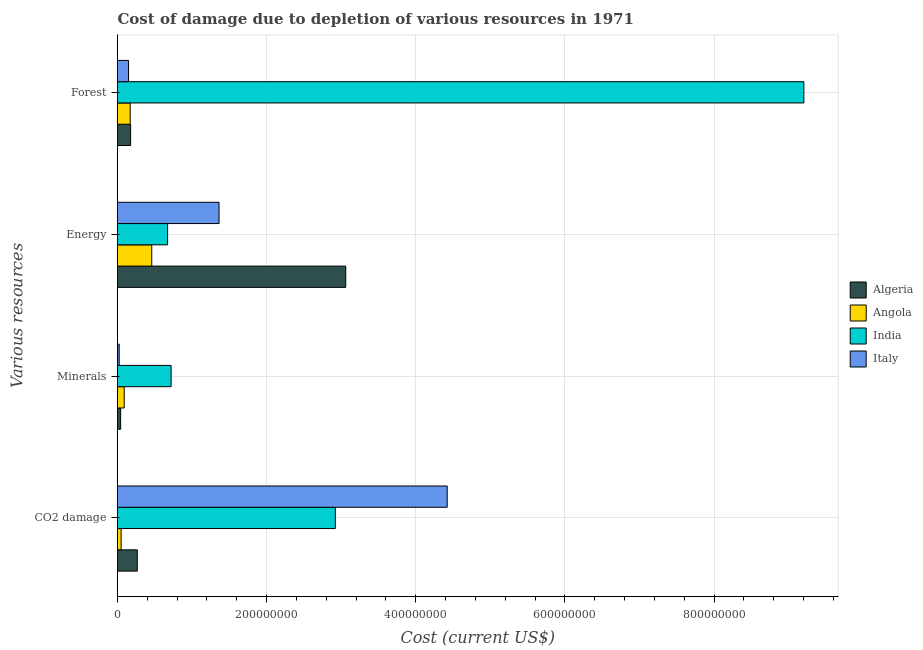How many different coloured bars are there?
Your answer should be very brief. 4. Are the number of bars per tick equal to the number of legend labels?
Offer a terse response. Yes. Are the number of bars on each tick of the Y-axis equal?
Provide a succinct answer. Yes. How many bars are there on the 2nd tick from the top?
Make the answer very short. 4. What is the label of the 1st group of bars from the top?
Ensure brevity in your answer.  Forest. What is the cost of damage due to depletion of minerals in Algeria?
Your answer should be compact. 4.19e+06. Across all countries, what is the maximum cost of damage due to depletion of minerals?
Offer a very short reply. 7.19e+07. Across all countries, what is the minimum cost of damage due to depletion of coal?
Make the answer very short. 4.84e+06. In which country was the cost of damage due to depletion of energy maximum?
Your response must be concise. Algeria. In which country was the cost of damage due to depletion of minerals minimum?
Give a very brief answer. Italy. What is the total cost of damage due to depletion of coal in the graph?
Your response must be concise. 7.66e+08. What is the difference between the cost of damage due to depletion of energy in Angola and that in Algeria?
Offer a terse response. -2.60e+08. What is the difference between the cost of damage due to depletion of forests in Algeria and the cost of damage due to depletion of minerals in India?
Ensure brevity in your answer.  -5.43e+07. What is the average cost of damage due to depletion of minerals per country?
Keep it short and to the point. 2.18e+07. What is the difference between the cost of damage due to depletion of energy and cost of damage due to depletion of coal in Italy?
Keep it short and to the point. -3.06e+08. In how many countries, is the cost of damage due to depletion of forests greater than 480000000 US$?
Provide a succinct answer. 1. What is the ratio of the cost of damage due to depletion of coal in Angola to that in Italy?
Keep it short and to the point. 0.01. Is the difference between the cost of damage due to depletion of energy in Algeria and Angola greater than the difference between the cost of damage due to depletion of coal in Algeria and Angola?
Provide a succinct answer. Yes. What is the difference between the highest and the second highest cost of damage due to depletion of minerals?
Offer a terse response. 6.29e+07. What is the difference between the highest and the lowest cost of damage due to depletion of forests?
Keep it short and to the point. 9.06e+08. In how many countries, is the cost of damage due to depletion of energy greater than the average cost of damage due to depletion of energy taken over all countries?
Keep it short and to the point. 1. Is the sum of the cost of damage due to depletion of energy in India and Algeria greater than the maximum cost of damage due to depletion of minerals across all countries?
Your answer should be very brief. Yes. What does the 1st bar from the top in Minerals represents?
Provide a short and direct response. Italy. Is it the case that in every country, the sum of the cost of damage due to depletion of coal and cost of damage due to depletion of minerals is greater than the cost of damage due to depletion of energy?
Your response must be concise. No. How many bars are there?
Your answer should be compact. 16. How many countries are there in the graph?
Give a very brief answer. 4. Are the values on the major ticks of X-axis written in scientific E-notation?
Keep it short and to the point. No. Does the graph contain grids?
Provide a short and direct response. Yes. How are the legend labels stacked?
Make the answer very short. Vertical. What is the title of the graph?
Your answer should be very brief. Cost of damage due to depletion of various resources in 1971 . Does "United States" appear as one of the legend labels in the graph?
Your response must be concise. No. What is the label or title of the X-axis?
Offer a terse response. Cost (current US$). What is the label or title of the Y-axis?
Your answer should be compact. Various resources. What is the Cost (current US$) of Algeria in CO2 damage?
Make the answer very short. 2.65e+07. What is the Cost (current US$) of Angola in CO2 damage?
Make the answer very short. 4.84e+06. What is the Cost (current US$) in India in CO2 damage?
Offer a very short reply. 2.92e+08. What is the Cost (current US$) of Italy in CO2 damage?
Your answer should be very brief. 4.42e+08. What is the Cost (current US$) of Algeria in Minerals?
Your answer should be very brief. 4.19e+06. What is the Cost (current US$) in Angola in Minerals?
Give a very brief answer. 8.98e+06. What is the Cost (current US$) in India in Minerals?
Provide a short and direct response. 7.19e+07. What is the Cost (current US$) in Italy in Minerals?
Your answer should be very brief. 2.28e+06. What is the Cost (current US$) of Algeria in Energy?
Your answer should be very brief. 3.06e+08. What is the Cost (current US$) in Angola in Energy?
Provide a succinct answer. 4.59e+07. What is the Cost (current US$) in India in Energy?
Provide a short and direct response. 6.72e+07. What is the Cost (current US$) in Italy in Energy?
Offer a very short reply. 1.36e+08. What is the Cost (current US$) in Algeria in Forest?
Provide a succinct answer. 1.76e+07. What is the Cost (current US$) of Angola in Forest?
Ensure brevity in your answer.  1.70e+07. What is the Cost (current US$) of India in Forest?
Your answer should be compact. 9.20e+08. What is the Cost (current US$) in Italy in Forest?
Your answer should be compact. 1.48e+07. Across all Various resources, what is the maximum Cost (current US$) in Algeria?
Give a very brief answer. 3.06e+08. Across all Various resources, what is the maximum Cost (current US$) of Angola?
Offer a very short reply. 4.59e+07. Across all Various resources, what is the maximum Cost (current US$) in India?
Keep it short and to the point. 9.20e+08. Across all Various resources, what is the maximum Cost (current US$) of Italy?
Give a very brief answer. 4.42e+08. Across all Various resources, what is the minimum Cost (current US$) in Algeria?
Provide a short and direct response. 4.19e+06. Across all Various resources, what is the minimum Cost (current US$) of Angola?
Give a very brief answer. 4.84e+06. Across all Various resources, what is the minimum Cost (current US$) of India?
Your response must be concise. 6.72e+07. Across all Various resources, what is the minimum Cost (current US$) of Italy?
Your answer should be compact. 2.28e+06. What is the total Cost (current US$) in Algeria in the graph?
Your answer should be compact. 3.54e+08. What is the total Cost (current US$) in Angola in the graph?
Make the answer very short. 7.68e+07. What is the total Cost (current US$) of India in the graph?
Your response must be concise. 1.35e+09. What is the total Cost (current US$) of Italy in the graph?
Offer a terse response. 5.95e+08. What is the difference between the Cost (current US$) in Algeria in CO2 damage and that in Minerals?
Your answer should be compact. 2.23e+07. What is the difference between the Cost (current US$) of Angola in CO2 damage and that in Minerals?
Your answer should be compact. -4.14e+06. What is the difference between the Cost (current US$) in India in CO2 damage and that in Minerals?
Provide a succinct answer. 2.20e+08. What is the difference between the Cost (current US$) in Italy in CO2 damage and that in Minerals?
Make the answer very short. 4.40e+08. What is the difference between the Cost (current US$) of Algeria in CO2 damage and that in Energy?
Your answer should be very brief. -2.80e+08. What is the difference between the Cost (current US$) in Angola in CO2 damage and that in Energy?
Your answer should be very brief. -4.11e+07. What is the difference between the Cost (current US$) of India in CO2 damage and that in Energy?
Ensure brevity in your answer.  2.25e+08. What is the difference between the Cost (current US$) in Italy in CO2 damage and that in Energy?
Offer a terse response. 3.06e+08. What is the difference between the Cost (current US$) in Algeria in CO2 damage and that in Forest?
Your answer should be compact. 8.90e+06. What is the difference between the Cost (current US$) in Angola in CO2 damage and that in Forest?
Your response must be concise. -1.22e+07. What is the difference between the Cost (current US$) in India in CO2 damage and that in Forest?
Offer a terse response. -6.28e+08. What is the difference between the Cost (current US$) in Italy in CO2 damage and that in Forest?
Provide a succinct answer. 4.27e+08. What is the difference between the Cost (current US$) of Algeria in Minerals and that in Energy?
Your answer should be very brief. -3.02e+08. What is the difference between the Cost (current US$) in Angola in Minerals and that in Energy?
Make the answer very short. -3.69e+07. What is the difference between the Cost (current US$) in India in Minerals and that in Energy?
Your answer should be very brief. 4.70e+06. What is the difference between the Cost (current US$) of Italy in Minerals and that in Energy?
Your response must be concise. -1.34e+08. What is the difference between the Cost (current US$) in Algeria in Minerals and that in Forest?
Ensure brevity in your answer.  -1.34e+07. What is the difference between the Cost (current US$) in Angola in Minerals and that in Forest?
Your answer should be very brief. -8.02e+06. What is the difference between the Cost (current US$) of India in Minerals and that in Forest?
Make the answer very short. -8.49e+08. What is the difference between the Cost (current US$) in Italy in Minerals and that in Forest?
Make the answer very short. -1.25e+07. What is the difference between the Cost (current US$) of Algeria in Energy and that in Forest?
Your answer should be very brief. 2.88e+08. What is the difference between the Cost (current US$) in Angola in Energy and that in Forest?
Your answer should be very brief. 2.89e+07. What is the difference between the Cost (current US$) in India in Energy and that in Forest?
Your response must be concise. -8.53e+08. What is the difference between the Cost (current US$) in Italy in Energy and that in Forest?
Make the answer very short. 1.21e+08. What is the difference between the Cost (current US$) in Algeria in CO2 damage and the Cost (current US$) in Angola in Minerals?
Keep it short and to the point. 1.75e+07. What is the difference between the Cost (current US$) of Algeria in CO2 damage and the Cost (current US$) of India in Minerals?
Provide a succinct answer. -4.54e+07. What is the difference between the Cost (current US$) in Algeria in CO2 damage and the Cost (current US$) in Italy in Minerals?
Ensure brevity in your answer.  2.42e+07. What is the difference between the Cost (current US$) of Angola in CO2 damage and the Cost (current US$) of India in Minerals?
Your answer should be very brief. -6.71e+07. What is the difference between the Cost (current US$) of Angola in CO2 damage and the Cost (current US$) of Italy in Minerals?
Keep it short and to the point. 2.56e+06. What is the difference between the Cost (current US$) in India in CO2 damage and the Cost (current US$) in Italy in Minerals?
Your answer should be compact. 2.90e+08. What is the difference between the Cost (current US$) of Algeria in CO2 damage and the Cost (current US$) of Angola in Energy?
Your answer should be very brief. -1.94e+07. What is the difference between the Cost (current US$) in Algeria in CO2 damage and the Cost (current US$) in India in Energy?
Provide a succinct answer. -4.07e+07. What is the difference between the Cost (current US$) of Algeria in CO2 damage and the Cost (current US$) of Italy in Energy?
Offer a terse response. -1.10e+08. What is the difference between the Cost (current US$) in Angola in CO2 damage and the Cost (current US$) in India in Energy?
Make the answer very short. -6.24e+07. What is the difference between the Cost (current US$) in Angola in CO2 damage and the Cost (current US$) in Italy in Energy?
Offer a very short reply. -1.31e+08. What is the difference between the Cost (current US$) in India in CO2 damage and the Cost (current US$) in Italy in Energy?
Your answer should be compact. 1.56e+08. What is the difference between the Cost (current US$) of Algeria in CO2 damage and the Cost (current US$) of Angola in Forest?
Provide a succinct answer. 9.49e+06. What is the difference between the Cost (current US$) in Algeria in CO2 damage and the Cost (current US$) in India in Forest?
Give a very brief answer. -8.94e+08. What is the difference between the Cost (current US$) in Algeria in CO2 damage and the Cost (current US$) in Italy in Forest?
Your response must be concise. 1.17e+07. What is the difference between the Cost (current US$) of Angola in CO2 damage and the Cost (current US$) of India in Forest?
Ensure brevity in your answer.  -9.16e+08. What is the difference between the Cost (current US$) in Angola in CO2 damage and the Cost (current US$) in Italy in Forest?
Your answer should be compact. -9.95e+06. What is the difference between the Cost (current US$) in India in CO2 damage and the Cost (current US$) in Italy in Forest?
Provide a succinct answer. 2.77e+08. What is the difference between the Cost (current US$) in Algeria in Minerals and the Cost (current US$) in Angola in Energy?
Offer a very short reply. -4.17e+07. What is the difference between the Cost (current US$) in Algeria in Minerals and the Cost (current US$) in India in Energy?
Give a very brief answer. -6.30e+07. What is the difference between the Cost (current US$) in Algeria in Minerals and the Cost (current US$) in Italy in Energy?
Ensure brevity in your answer.  -1.32e+08. What is the difference between the Cost (current US$) in Angola in Minerals and the Cost (current US$) in India in Energy?
Your response must be concise. -5.82e+07. What is the difference between the Cost (current US$) in Angola in Minerals and the Cost (current US$) in Italy in Energy?
Your answer should be compact. -1.27e+08. What is the difference between the Cost (current US$) of India in Minerals and the Cost (current US$) of Italy in Energy?
Provide a succinct answer. -6.43e+07. What is the difference between the Cost (current US$) of Algeria in Minerals and the Cost (current US$) of Angola in Forest?
Your answer should be compact. -1.28e+07. What is the difference between the Cost (current US$) of Algeria in Minerals and the Cost (current US$) of India in Forest?
Offer a very short reply. -9.16e+08. What is the difference between the Cost (current US$) in Algeria in Minerals and the Cost (current US$) in Italy in Forest?
Offer a terse response. -1.06e+07. What is the difference between the Cost (current US$) of Angola in Minerals and the Cost (current US$) of India in Forest?
Provide a succinct answer. -9.12e+08. What is the difference between the Cost (current US$) of Angola in Minerals and the Cost (current US$) of Italy in Forest?
Offer a very short reply. -5.81e+06. What is the difference between the Cost (current US$) in India in Minerals and the Cost (current US$) in Italy in Forest?
Your answer should be very brief. 5.71e+07. What is the difference between the Cost (current US$) in Algeria in Energy and the Cost (current US$) in Angola in Forest?
Your answer should be compact. 2.89e+08. What is the difference between the Cost (current US$) of Algeria in Energy and the Cost (current US$) of India in Forest?
Provide a short and direct response. -6.14e+08. What is the difference between the Cost (current US$) of Algeria in Energy and the Cost (current US$) of Italy in Forest?
Offer a terse response. 2.91e+08. What is the difference between the Cost (current US$) in Angola in Energy and the Cost (current US$) in India in Forest?
Make the answer very short. -8.75e+08. What is the difference between the Cost (current US$) of Angola in Energy and the Cost (current US$) of Italy in Forest?
Your response must be concise. 3.11e+07. What is the difference between the Cost (current US$) in India in Energy and the Cost (current US$) in Italy in Forest?
Offer a very short reply. 5.24e+07. What is the average Cost (current US$) of Algeria per Various resources?
Your answer should be very brief. 8.86e+07. What is the average Cost (current US$) in Angola per Various resources?
Keep it short and to the point. 1.92e+07. What is the average Cost (current US$) of India per Various resources?
Offer a very short reply. 3.38e+08. What is the average Cost (current US$) of Italy per Various resources?
Offer a very short reply. 1.49e+08. What is the difference between the Cost (current US$) of Algeria and Cost (current US$) of Angola in CO2 damage?
Provide a short and direct response. 2.17e+07. What is the difference between the Cost (current US$) of Algeria and Cost (current US$) of India in CO2 damage?
Keep it short and to the point. -2.66e+08. What is the difference between the Cost (current US$) in Algeria and Cost (current US$) in Italy in CO2 damage?
Ensure brevity in your answer.  -4.16e+08. What is the difference between the Cost (current US$) of Angola and Cost (current US$) of India in CO2 damage?
Provide a short and direct response. -2.87e+08. What is the difference between the Cost (current US$) of Angola and Cost (current US$) of Italy in CO2 damage?
Your response must be concise. -4.37e+08. What is the difference between the Cost (current US$) of India and Cost (current US$) of Italy in CO2 damage?
Offer a very short reply. -1.50e+08. What is the difference between the Cost (current US$) in Algeria and Cost (current US$) in Angola in Minerals?
Your answer should be very brief. -4.79e+06. What is the difference between the Cost (current US$) in Algeria and Cost (current US$) in India in Minerals?
Offer a very short reply. -6.77e+07. What is the difference between the Cost (current US$) in Algeria and Cost (current US$) in Italy in Minerals?
Keep it short and to the point. 1.91e+06. What is the difference between the Cost (current US$) of Angola and Cost (current US$) of India in Minerals?
Make the answer very short. -6.29e+07. What is the difference between the Cost (current US$) in Angola and Cost (current US$) in Italy in Minerals?
Provide a short and direct response. 6.70e+06. What is the difference between the Cost (current US$) in India and Cost (current US$) in Italy in Minerals?
Make the answer very short. 6.96e+07. What is the difference between the Cost (current US$) in Algeria and Cost (current US$) in Angola in Energy?
Your answer should be compact. 2.60e+08. What is the difference between the Cost (current US$) in Algeria and Cost (current US$) in India in Energy?
Your response must be concise. 2.39e+08. What is the difference between the Cost (current US$) in Algeria and Cost (current US$) in Italy in Energy?
Offer a terse response. 1.70e+08. What is the difference between the Cost (current US$) of Angola and Cost (current US$) of India in Energy?
Offer a very short reply. -2.13e+07. What is the difference between the Cost (current US$) of Angola and Cost (current US$) of Italy in Energy?
Give a very brief answer. -9.03e+07. What is the difference between the Cost (current US$) of India and Cost (current US$) of Italy in Energy?
Your response must be concise. -6.90e+07. What is the difference between the Cost (current US$) in Algeria and Cost (current US$) in Angola in Forest?
Offer a terse response. 5.88e+05. What is the difference between the Cost (current US$) in Algeria and Cost (current US$) in India in Forest?
Your answer should be very brief. -9.03e+08. What is the difference between the Cost (current US$) in Algeria and Cost (current US$) in Italy in Forest?
Your response must be concise. 2.80e+06. What is the difference between the Cost (current US$) of Angola and Cost (current US$) of India in Forest?
Ensure brevity in your answer.  -9.03e+08. What is the difference between the Cost (current US$) in Angola and Cost (current US$) in Italy in Forest?
Make the answer very short. 2.21e+06. What is the difference between the Cost (current US$) in India and Cost (current US$) in Italy in Forest?
Provide a succinct answer. 9.06e+08. What is the ratio of the Cost (current US$) in Algeria in CO2 damage to that in Minerals?
Keep it short and to the point. 6.32. What is the ratio of the Cost (current US$) of Angola in CO2 damage to that in Minerals?
Make the answer very short. 0.54. What is the ratio of the Cost (current US$) in India in CO2 damage to that in Minerals?
Offer a very short reply. 4.06. What is the ratio of the Cost (current US$) of Italy in CO2 damage to that in Minerals?
Ensure brevity in your answer.  193.94. What is the ratio of the Cost (current US$) of Algeria in CO2 damage to that in Energy?
Offer a very short reply. 0.09. What is the ratio of the Cost (current US$) of Angola in CO2 damage to that in Energy?
Your answer should be compact. 0.11. What is the ratio of the Cost (current US$) of India in CO2 damage to that in Energy?
Provide a short and direct response. 4.35. What is the ratio of the Cost (current US$) of Italy in CO2 damage to that in Energy?
Ensure brevity in your answer.  3.25. What is the ratio of the Cost (current US$) in Algeria in CO2 damage to that in Forest?
Provide a short and direct response. 1.51. What is the ratio of the Cost (current US$) in Angola in CO2 damage to that in Forest?
Your answer should be very brief. 0.28. What is the ratio of the Cost (current US$) of India in CO2 damage to that in Forest?
Offer a terse response. 0.32. What is the ratio of the Cost (current US$) in Italy in CO2 damage to that in Forest?
Your response must be concise. 29.9. What is the ratio of the Cost (current US$) in Algeria in Minerals to that in Energy?
Make the answer very short. 0.01. What is the ratio of the Cost (current US$) of Angola in Minerals to that in Energy?
Make the answer very short. 0.2. What is the ratio of the Cost (current US$) in India in Minerals to that in Energy?
Provide a succinct answer. 1.07. What is the ratio of the Cost (current US$) of Italy in Minerals to that in Energy?
Give a very brief answer. 0.02. What is the ratio of the Cost (current US$) in Algeria in Minerals to that in Forest?
Make the answer very short. 0.24. What is the ratio of the Cost (current US$) of Angola in Minerals to that in Forest?
Keep it short and to the point. 0.53. What is the ratio of the Cost (current US$) in India in Minerals to that in Forest?
Offer a terse response. 0.08. What is the ratio of the Cost (current US$) in Italy in Minerals to that in Forest?
Offer a very short reply. 0.15. What is the ratio of the Cost (current US$) in Algeria in Energy to that in Forest?
Keep it short and to the point. 17.4. What is the ratio of the Cost (current US$) of Angola in Energy to that in Forest?
Make the answer very short. 2.7. What is the ratio of the Cost (current US$) of India in Energy to that in Forest?
Keep it short and to the point. 0.07. What is the ratio of the Cost (current US$) of Italy in Energy to that in Forest?
Give a very brief answer. 9.21. What is the difference between the highest and the second highest Cost (current US$) of Algeria?
Your answer should be compact. 2.80e+08. What is the difference between the highest and the second highest Cost (current US$) in Angola?
Make the answer very short. 2.89e+07. What is the difference between the highest and the second highest Cost (current US$) of India?
Provide a succinct answer. 6.28e+08. What is the difference between the highest and the second highest Cost (current US$) of Italy?
Give a very brief answer. 3.06e+08. What is the difference between the highest and the lowest Cost (current US$) of Algeria?
Provide a succinct answer. 3.02e+08. What is the difference between the highest and the lowest Cost (current US$) of Angola?
Your answer should be compact. 4.11e+07. What is the difference between the highest and the lowest Cost (current US$) in India?
Offer a terse response. 8.53e+08. What is the difference between the highest and the lowest Cost (current US$) in Italy?
Offer a terse response. 4.40e+08. 